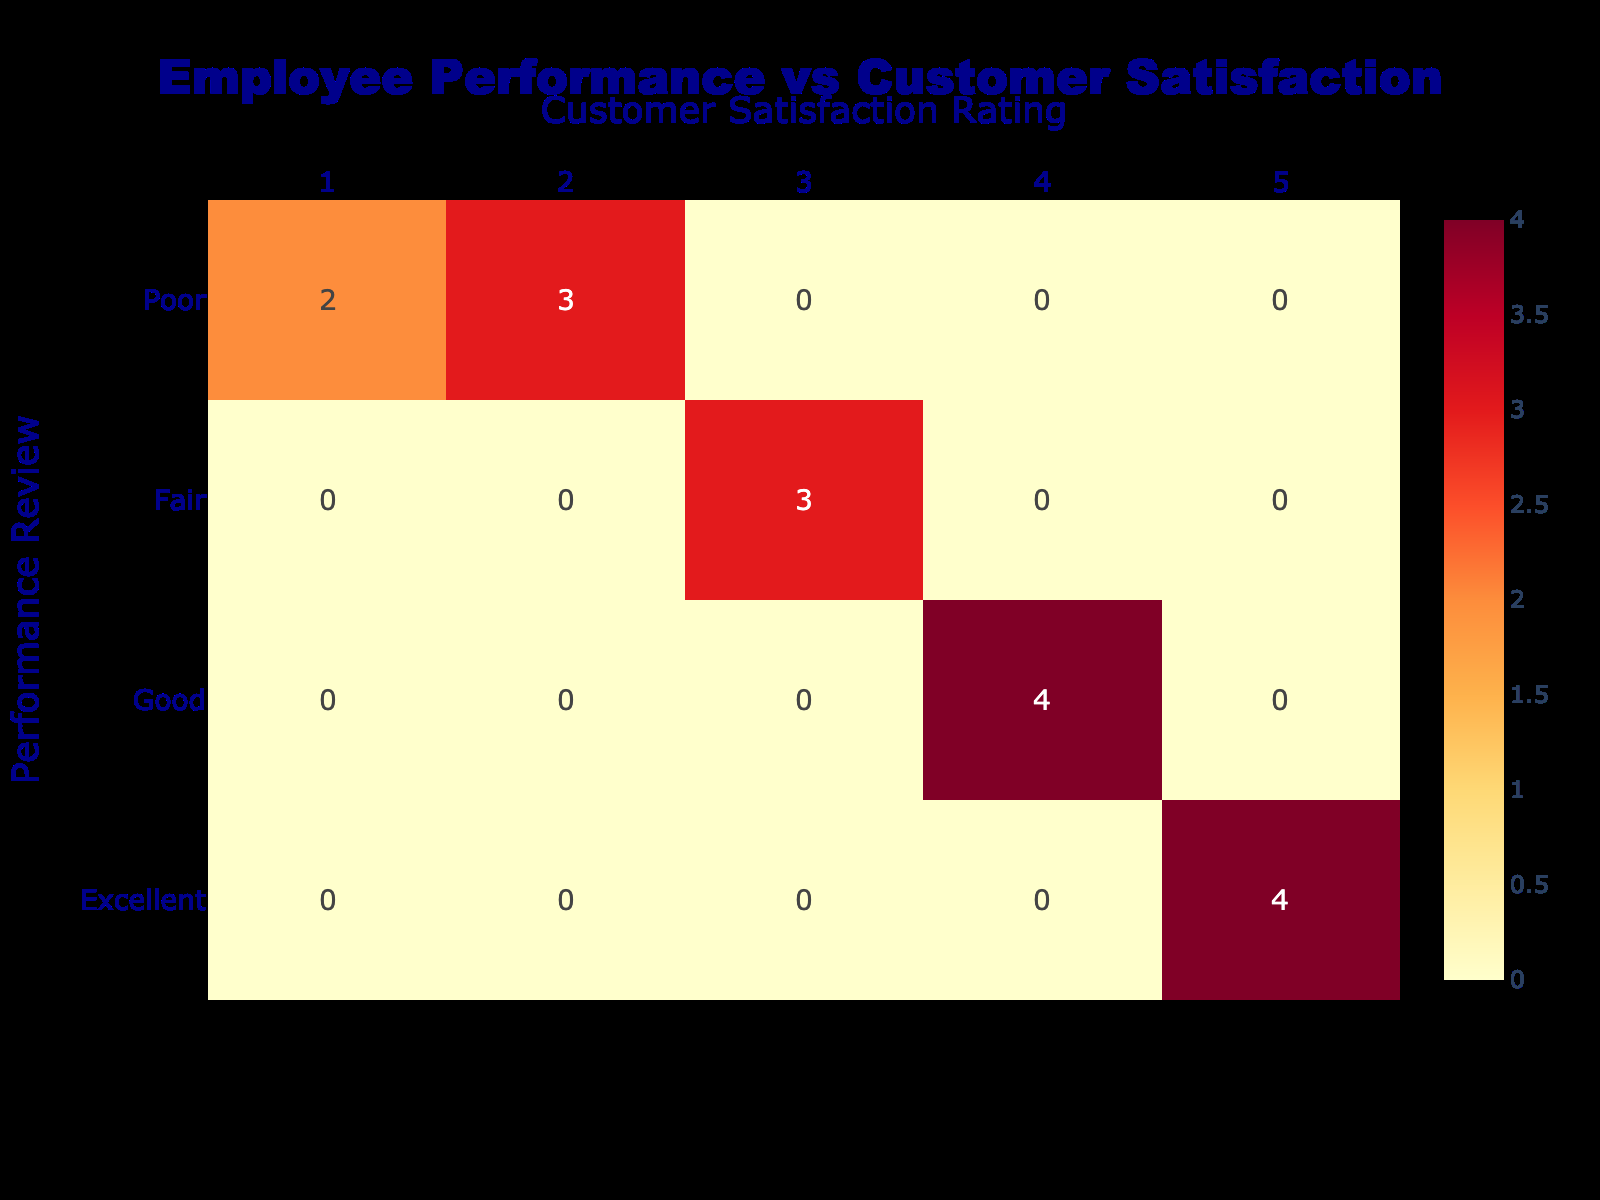What is the number of employees who received an 'Excellent' performance review? Counting the occurrences in the 'Excellent' row of the table, we see the values corresponding to satisfaction ratings of 5, which total 4 employees: Alice Johnson, Emily Davis, Ian Green, and Oscar Clark.
Answer: 4 What is the total number of employees who rated customer satisfaction as '1'? The '1' column under the satisfaction ratings shows 3 entries in the 'Poor' performance review row. Therefore, the total number of employees who rated customer satisfaction as '1' is 3: Frank Turner, Michael King, and Jessica Thompson.
Answer: 3 How many employees received a 'Good' performance review? Looking at the 'Good' row, the corresponding satisfaction ratings are 4: Bob Smith, Grace Lee, Kevin Baker, and Nina Martinez, totaling up to 4 employees receiving a 'Good' performance review.
Answer: 4 What is the average customer satisfaction rating for employees with a 'Fair' performance review? The employees with a 'Fair' review rated their satisfaction as follows: 3 (Charlie Brown), 3 (Hannah White), and 3 (Laura Harris). Thus, the average is (3 + 3 + 3)/3 = 3.
Answer: 3 Is it true that every employee with a 'Poor' performance review rated customer satisfaction as '2' or below? The 'Poor' performance review row includes satisfaction ratings of 1 and 2 from Frank Turner, Michael King, and Jessica Thompson, confirming that they all rated 2 or below. Therefore, the statement is true.
Answer: Yes Which performance review had the lowest customer satisfaction rating? By observing the satisfaction ratings, the lowest rating is '1', which corresponds to the 'Poor' performance review category containing 3 entries. Hence, the performance review with the lowest rating is 'Poor'.
Answer: Poor How many employees received a 'Good' performance review with a customer satisfaction rating of '5'? Looking under the 'Good' row, the customer satisfaction ratings of 5 show no entries, confirming that no employee received a 'Good' performance review with that rating.
Answer: 0 What is the difference in the number of employees between 'Excellent' and 'Poor' performance reviews? The number of employees with 'Excellent' reviews is 4 and with 'Poor' reviews is 5. Therefore, the difference is 5 - 4 = 1, indicating there is 1 more employee in the 'Poor' category than the 'Excellent' category.
Answer: 1 How many employees received identical ratings for performance reviews labeled 'Fair' and 'Good'? In the 'Fair' row, the ratings show 3 employees while in the 'Good' row there are 4. Hence, there are 0 employees rated identically, as 'Fair' does not overlap with 'Good'.
Answer: 0 